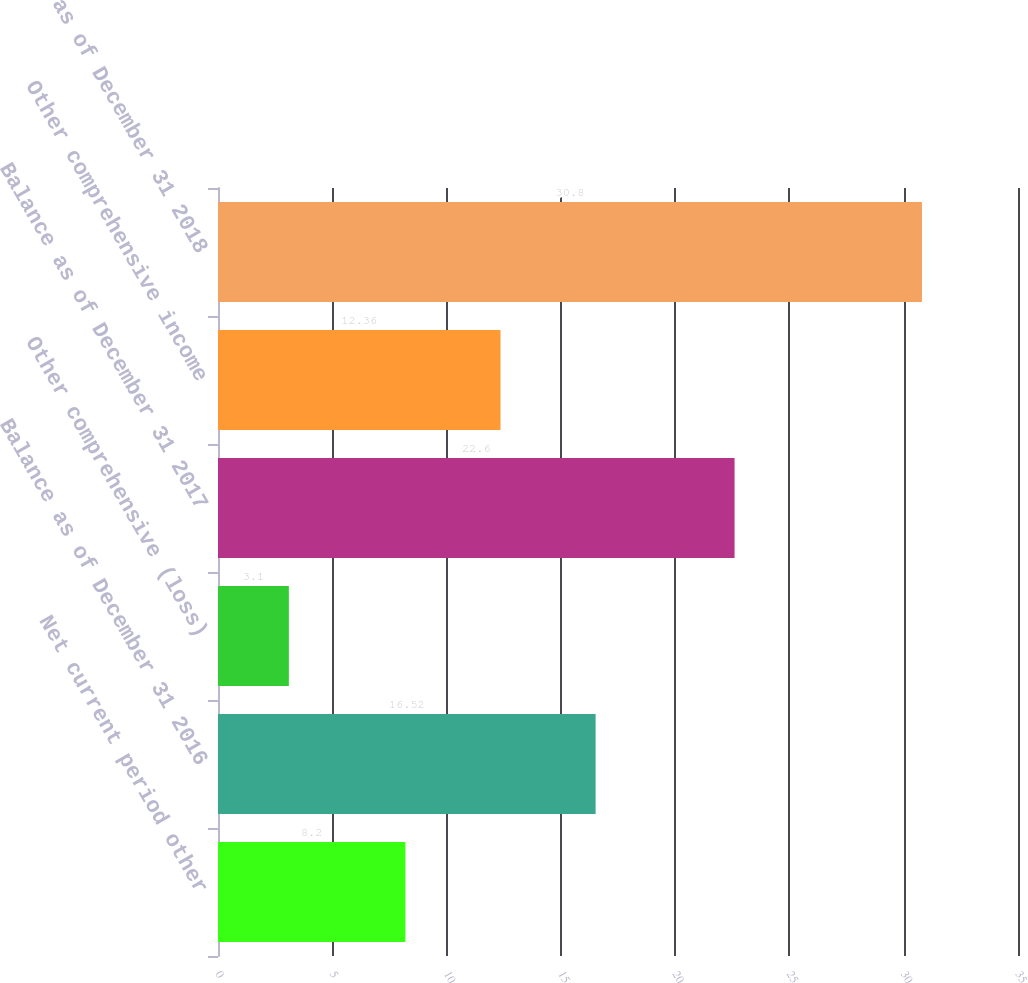Convert chart. <chart><loc_0><loc_0><loc_500><loc_500><bar_chart><fcel>Net current period other<fcel>Balance as of December 31 2016<fcel>Other comprehensive (loss)<fcel>Balance as of December 31 2017<fcel>Other comprehensive income<fcel>Balance as of December 31 2018<nl><fcel>8.2<fcel>16.52<fcel>3.1<fcel>22.6<fcel>12.36<fcel>30.8<nl></chart> 